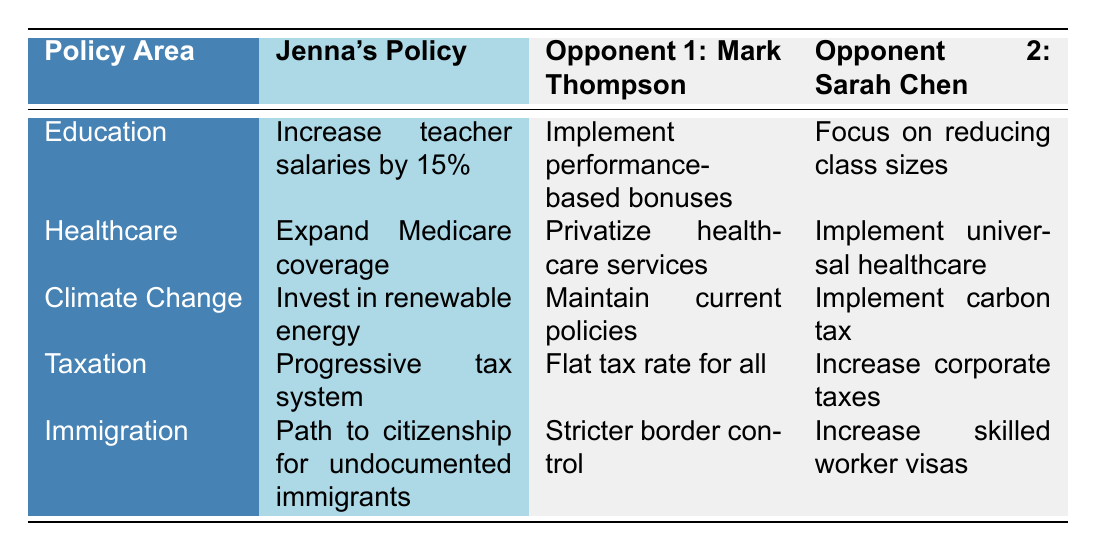What is Jenna's policy on education? Jenna's policy on education is to increase teacher salaries by 15%. This is directly stated in the table under the "Jenna's Policy" column for the "Education" policy area.
Answer: Increase teacher salaries by 15% What do Mark Thompson and Sarah Chen propose for the healthcare policy area? Mark Thompson proposes to privatize healthcare services, while Sarah Chen suggests implementing universal healthcare. These proposals are noted under their respective columns in the "Healthcare" row of the table.
Answer: Privatize healthcare services; Implement universal healthcare Is Jenna's policy on taxation different from Mark Thompson's policy? Yes, Jenna advocates for a progressive tax system, while Mark Thompson supports a flat tax rate for all, indicating a difference in their tax strategies as shown in the "Taxation" row.
Answer: Yes Which candidate supports a carbon tax in their climate change policy? Sarah Chen supports the implementation of a carbon tax, as listed under her policies in the "Climate Change" row, while Jenna and Mark Thompson have different approaches regarding climate change.
Answer: Sarah Chen What is the difference between Jenna's and Sarah Chen's immigration policies? Jenna's policy is to provide a path to citizenship for undocumented immigrants, while Sarah Chen's policy focuses on increasing skilled worker visas. This indicates differing priorities in their immigration approaches outlined in the "Immigration" row.
Answer: Path to citizenship vs. increase skilled worker visas Do both Mark Thompson and Jenna support increasing teacher salaries? No, Mark Thompson does not support increasing teacher salaries; instead, he wants to implement performance-based bonuses, contrasting Jenna's proposal of a 15% increase.
Answer: No Which candidates focus on renewable energy investment? Only Jenna focuses on investing in renewable energy in her climate change policy. Mark Thompson aims to maintain current policies, while Sarah Chen proposes a carbon tax, indicating that Jenna is the only one prioritizing renewable energy.
Answer: Jenna What is the overall commonality in healthcare policies between Mark Thompson and Sarah Chen? Both candidates propose significant changes to the healthcare system; however, they differ in their approaches, marking a commonality in seeking reforms but in very different directions. Mark wants privatization, while Sarah aims for universality.
Answer: Seeking significant reforms but different approaches Who has a more traditional approach to taxation, Jenna or Mark Thompson? Mark Thompson has a more traditional approach with a flat tax rate for all, whereas Jenna's progressive tax system represents a modern, more equitable approach to taxation.
Answer: Mark Thompson 